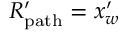<formula> <loc_0><loc_0><loc_500><loc_500>R _ { p a t h } ^ { \prime } = x _ { w } ^ { \prime }</formula> 